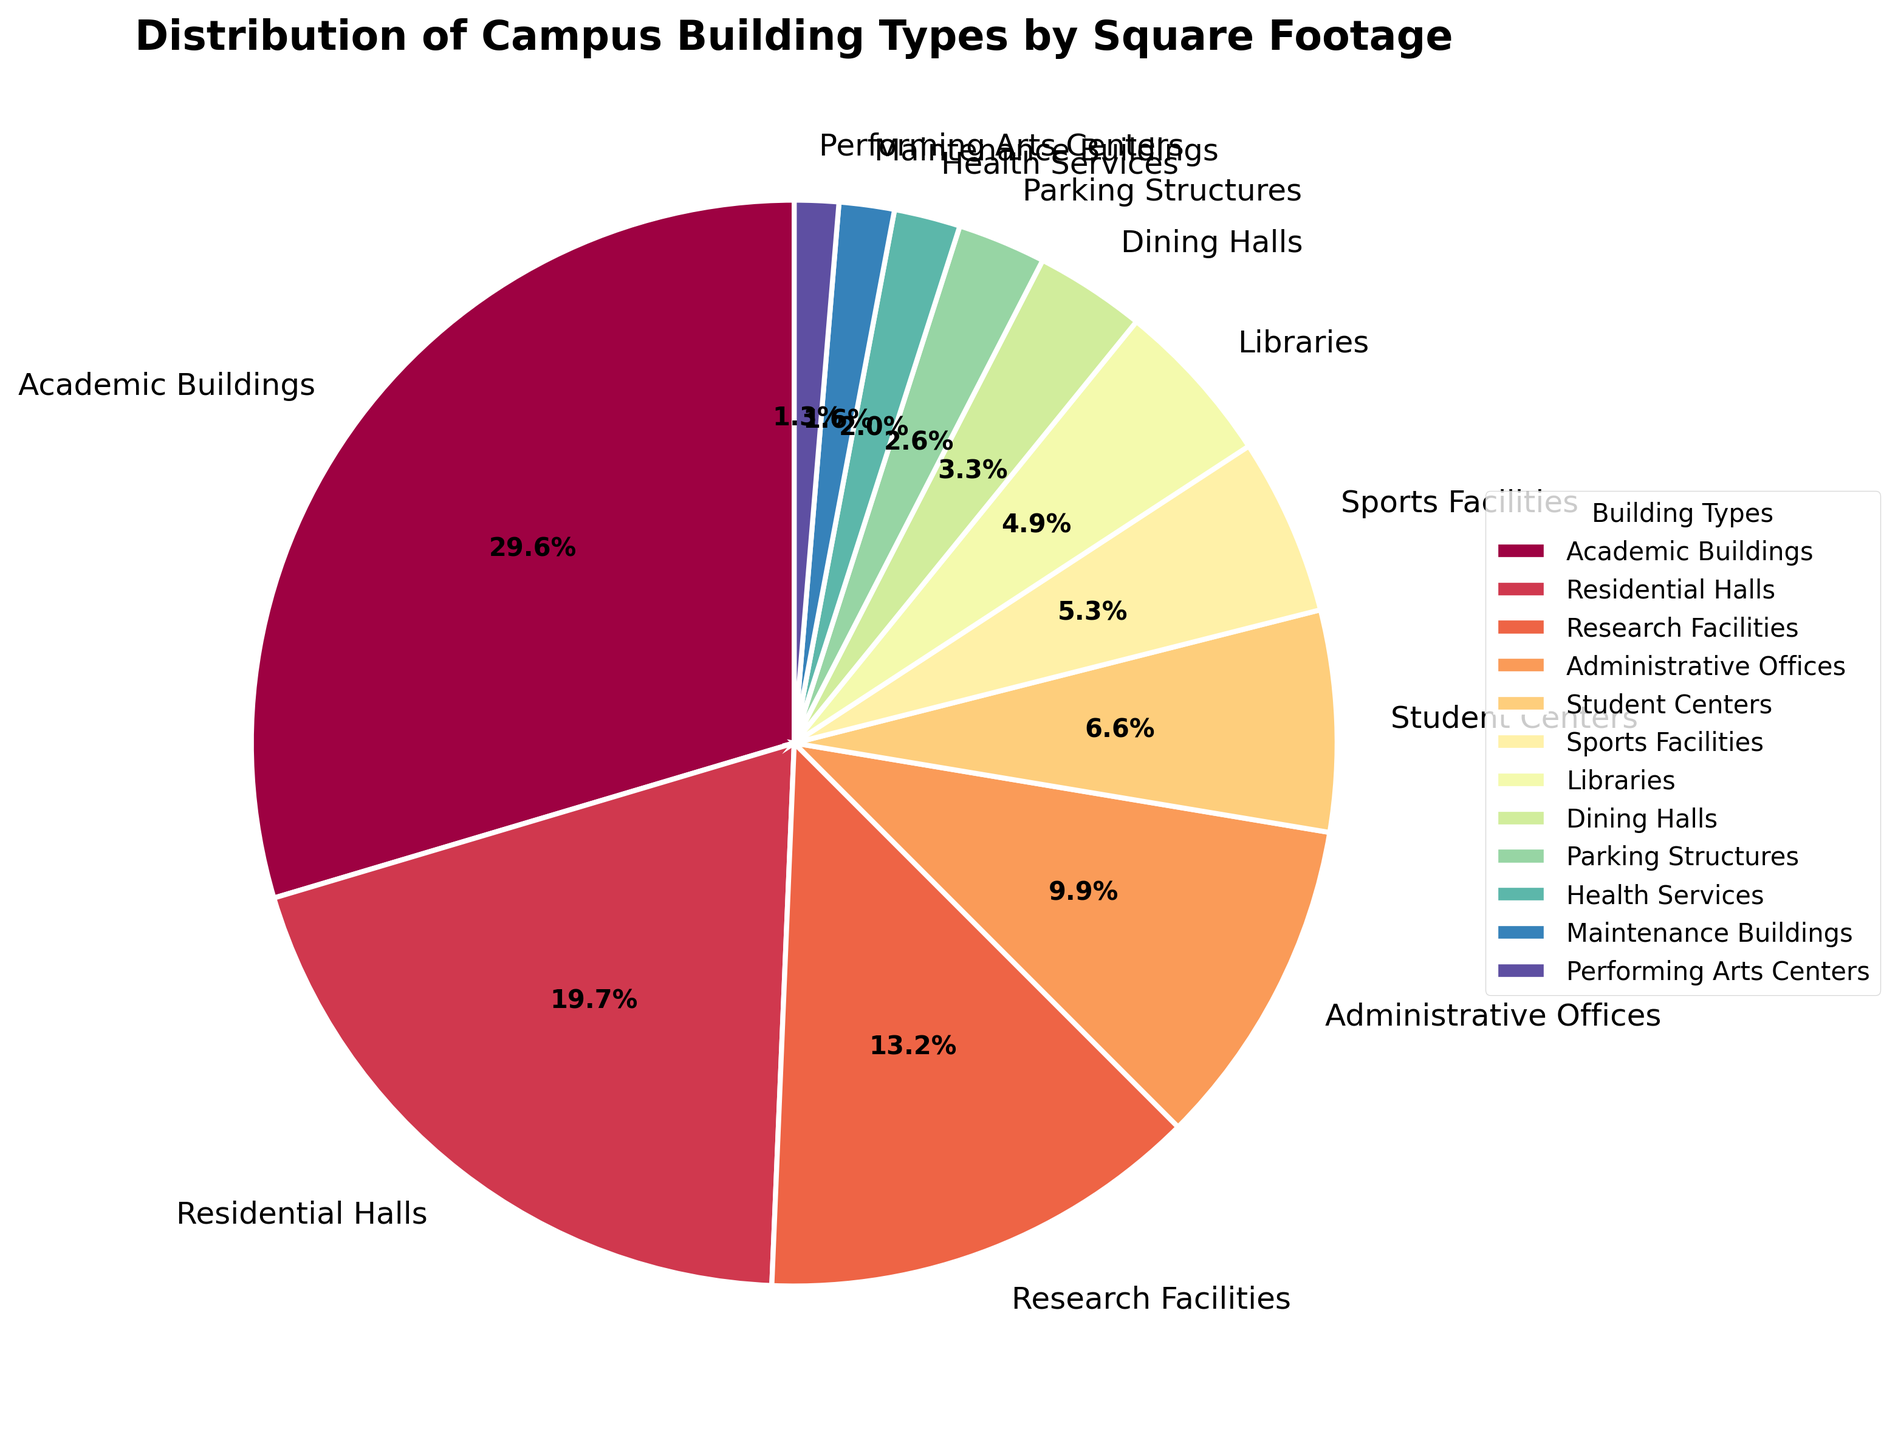What percentage of square footage does Research Facilities occupy? Research Facilities have 200,000 square feet out of the total, which we can identify from the label and percentages displayed on the pie chart. By looking at the corresponding percentage next to Research Facilities, we can directly read it.
Answer: 16.0% Which building type has the least square footage, and what is it? By visual inspection of the pie chart, we identify that Performing Arts Centers occupy the smallest portion of the chart. The exact square footage is given in the data conversion to the visual size (slice of the pie).
Answer: Performing Arts Centers, 20,000 square feet How does the square footage of Academic Buildings compare with that of Residential Halls? Looking at the pie chart, we see that Academic Buildings have a larger slice compared to Residential Halls. Specifically, the Academic Buildings occupy 450,000 sq ft, while Residential Halls occupy 300,000 sq ft.
Answer: Academic Buildings > Residential Halls What are the total square footage and percentage combined of Dining Halls and Parking Structures? Firstly, identify the individual square footages from the pie chart: Dining Halls (50,000 sq ft) and Parking Structures (40,000 sq ft). Add them to get the total: 50,000 + 40,000 = 90,000 sq ft. The combined percentage can be found by adding their displayed percentages on the chart: Dining Halls (5.0%) and Parking Structures (4.0%), giving a total of 9.0%.
Answer: 90,000 sq ft, 9.0% Which building type occupies more square footage, Libraries or Sports Facilities? By comparing the corresponding slices on the pie chart, we see that Sports Facilities have a slightly larger slice than Libraries. From the data, we see Sports Facilities have 80,000 sq ft, whereas Libraries have 75,000 sq ft.
Answer: Sports Facilities What is the difference in square footage between Health Services and Student Centers? Finding the slices for Health Services and Student Centers on the pie chart, we note their respective values: Health Services (30,000 sq ft) and Student Centers (100,000 sq ft). Subtracting the smaller from the larger gives us the difference: 100,000 - 30,000 = 70,000 sq ft.
Answer: 70,000 sq ft Is the square footage of Administrative Offices more or less than that of Research Facilities? From the pie chart, we can see that Research Facilities occupy a larger slice than Administrative Offices. Specifically, Administrative Offices have 150,000 sq ft, and Research Facilities have 200,000 sq ft.
Answer: Less What portion of the total square footage do the top three building types (by square footage) occupy together? Identify the top three building types and their square footage values from the chart. These are Academic Buildings (450,000 sq ft), Residential Halls (300,000 sq ft), and Research Facilities (200,000 sq ft). Sum them up for the total: 450,000 + 300,000 + 200,000 = 950,000 sq ft. To get the portion, divide this by the total square footage and multiply by 100 for the percentage: (950,000 / 1,715,000) * 100 = 55.4%.
Answer: 55.4% What are the second and third largest building types by square footage? From the pie chart, note the sizes and look for the second and third largest slices. The second largest is Residential Halls (300,000 sq ft) and the third is Research Facilities (200,000 sq ft).
Answer: Residential Halls, Research Facilities What is the combined square footage of all building types under 100,000 square feet? Identify the building types under 100,000 sq ft from the pie chart and their areas: Student Centers (100,000 sq ft), Sports Facilities (80,000 sq ft), Libraries (75,000 sq ft), Dining Halls (50,000 sq ft), Parking Structures (40,000 sq ft), Health Services (30,000 sq ft), Maintenance Buildings (25,000 sq ft), and Performing Arts Centers (20,000 sq ft). Add their square footages: 80,000 + 75,000 + 50,000 + 40,000 + 30,000 + 25,000 + 20,000 = 320,000 sq ft.
Answer: 320,000 sq ft 